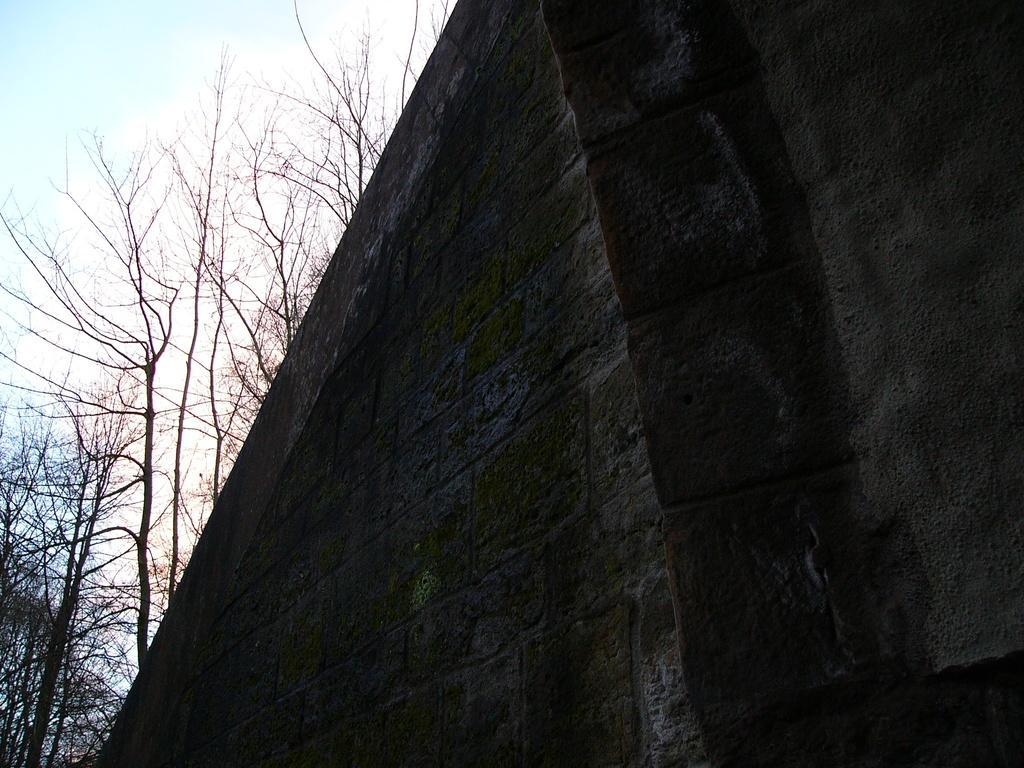Please provide a concise description of this image. There is a wall in the foreground area of the image and there are trees and sky in the background area. 